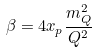<formula> <loc_0><loc_0><loc_500><loc_500>\beta = 4 x _ { p } \frac { m ^ { 2 } _ { Q } } { Q ^ { 2 } }</formula> 